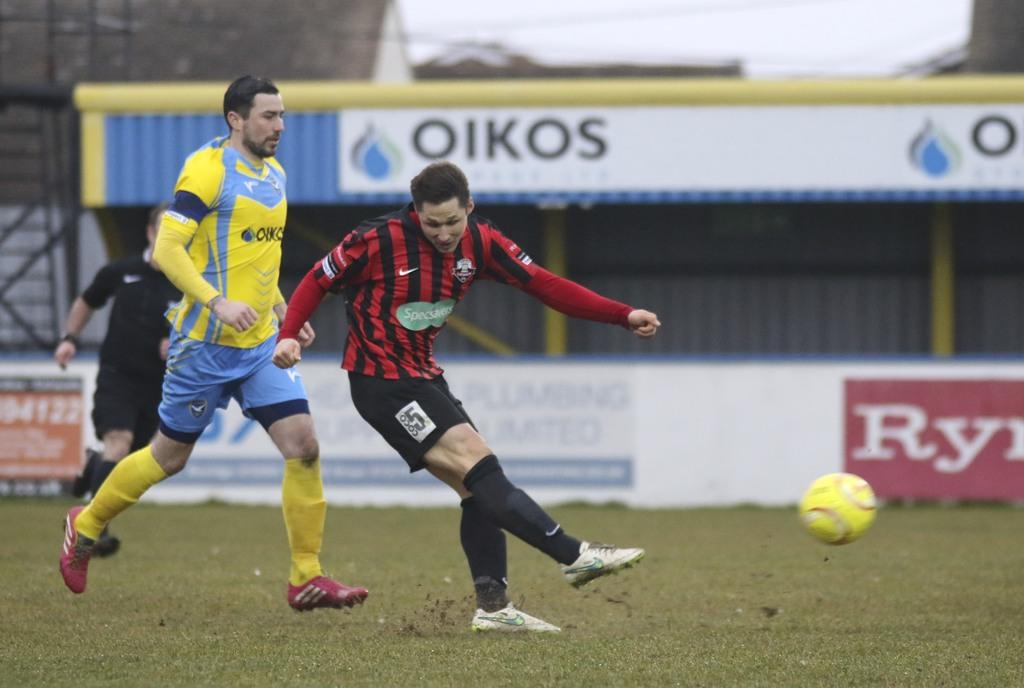What are the people in the image doing? The persons standing on the ground in the image are likely engaged in some activity or standing still. What can be seen in the background of the image? There is a shed and advertisement boards in the background of the image. What is located in the foreground of the image? There is a ball in the foreground of the image. What type of government is depicted on the ball in the image? There is no government depicted on the ball in the image; it is simply a ball. 